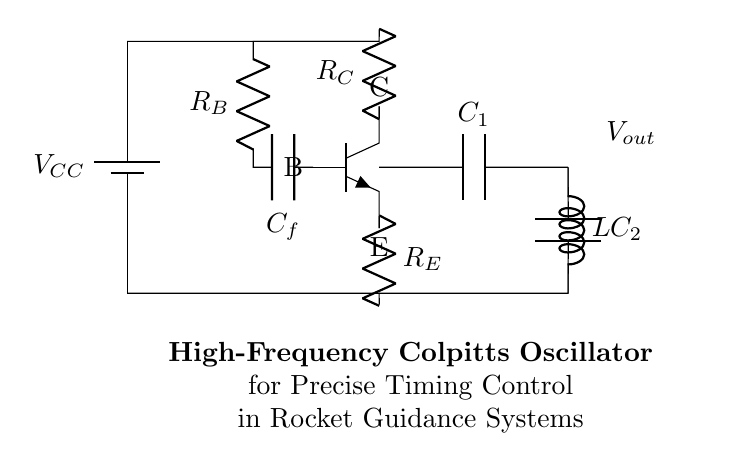What is the type of transistor used in the circuit? The circuit indicates an npn transistor, which is specified in the diagram with the label "npn".
Answer: npn What are the values of the capacitors in the tank circuit? In the tank circuit, two capacitors are indicated: C1 and C2. While specific numerical values are not given in the diagram, their labels serve as identifiers for further calculation or specification.
Answer: C1 and C2 What is the purpose of the feedback capacitor? The feedback capacitor, indicated as C_f, is used to provide feedback from the output back to the base of the transistor, which is essential for the oscillator's operation.
Answer: Feedback What is the function of the inductor in the tank circuit? The inductor, labeled L in the tank circuit, is critical as it works with the capacitors to determine the oscillation frequency of the oscillator, defining the resonant frequency along with C1 and C2.
Answer: Resonance What is the output voltage node labeled as? The output voltage is indicated by the node labeled "V_out," representing the point at which the oscillator's output frequency can be measured.
Answer: V_out How does the Colpitts oscillator achieve stability in its oscillation? The Colpitts oscillator achieves stability through the use of negative feedback provided by the feedback capacitor and resistor, which stabilizes the gain of the transistor, maintaining consistent oscillation.
Answer: Negative feedback 